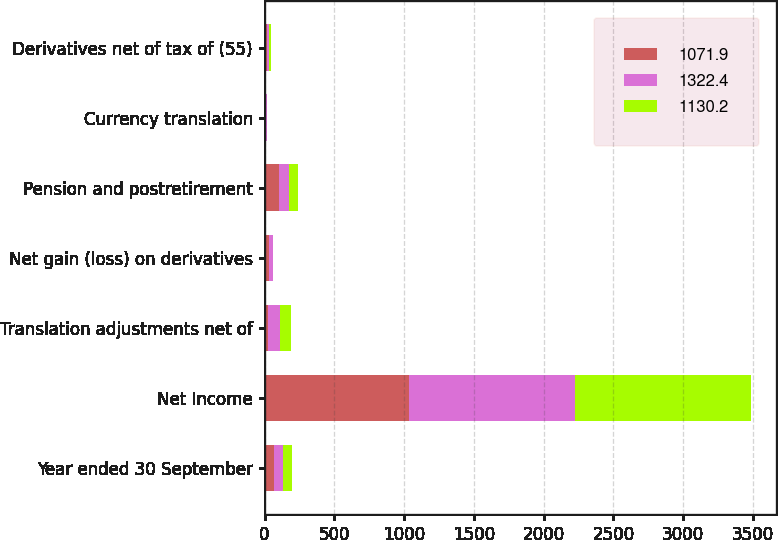Convert chart. <chart><loc_0><loc_0><loc_500><loc_500><stacked_bar_chart><ecel><fcel>Year ended 30 September<fcel>Net Income<fcel>Translation adjustments net of<fcel>Net gain (loss) on derivatives<fcel>Pension and postretirement<fcel>Currency translation<fcel>Derivatives net of tax of (55)<nl><fcel>1071.9<fcel>66.6<fcel>1032.5<fcel>25<fcel>35<fcel>104.9<fcel>0.6<fcel>20.2<nl><fcel>1322.4<fcel>66.6<fcel>1193.3<fcel>84.6<fcel>21.8<fcel>67<fcel>13.3<fcel>12.4<nl><fcel>1130.2<fcel>66.6<fcel>1261.5<fcel>82.8<fcel>0.8<fcel>67.7<fcel>0.4<fcel>11.5<nl></chart> 